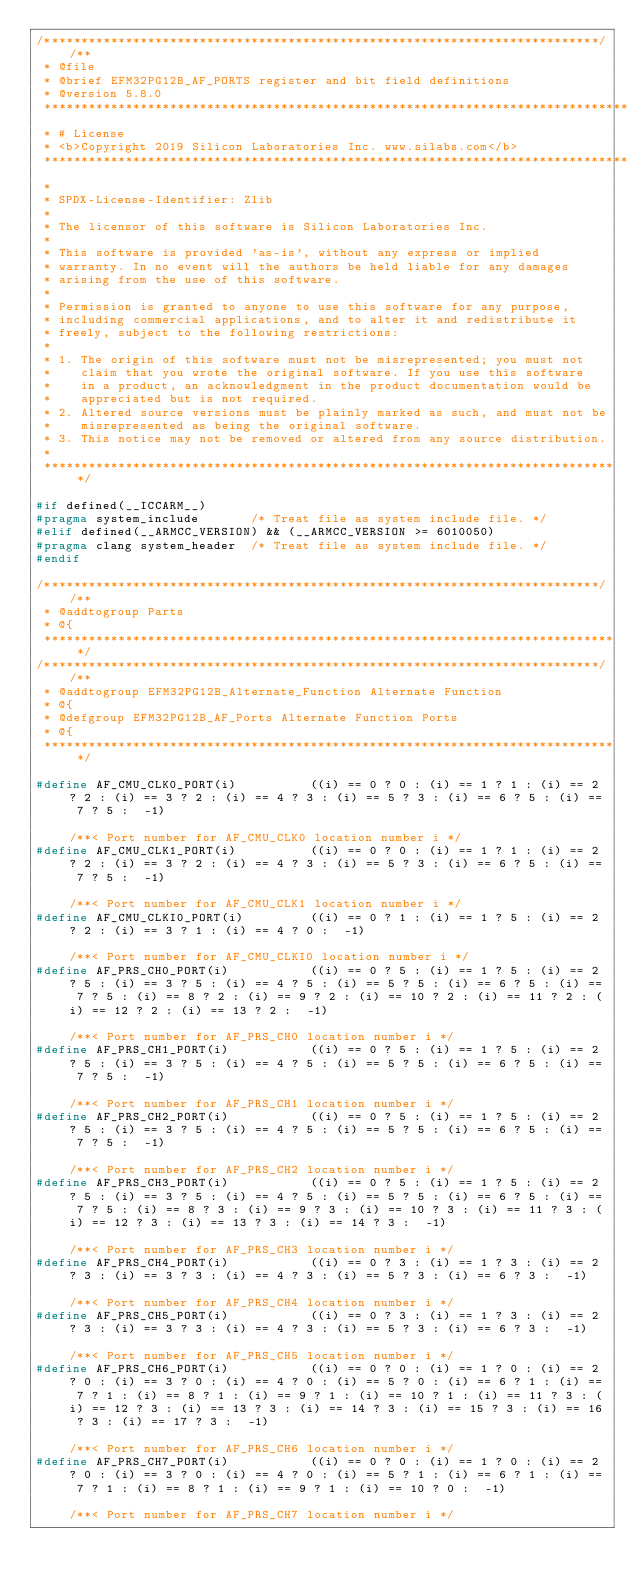<code> <loc_0><loc_0><loc_500><loc_500><_C_>/***************************************************************************//**
 * @file
 * @brief EFM32PG12B_AF_PORTS register and bit field definitions
 * @version 5.8.0
 *******************************************************************************
 * # License
 * <b>Copyright 2019 Silicon Laboratories Inc. www.silabs.com</b>
 *******************************************************************************
 *
 * SPDX-License-Identifier: Zlib
 *
 * The licensor of this software is Silicon Laboratories Inc.
 *
 * This software is provided 'as-is', without any express or implied
 * warranty. In no event will the authors be held liable for any damages
 * arising from the use of this software.
 *
 * Permission is granted to anyone to use this software for any purpose,
 * including commercial applications, and to alter it and redistribute it
 * freely, subject to the following restrictions:
 *
 * 1. The origin of this software must not be misrepresented; you must not
 *    claim that you wrote the original software. If you use this software
 *    in a product, an acknowledgment in the product documentation would be
 *    appreciated but is not required.
 * 2. Altered source versions must be plainly marked as such, and must not be
 *    misrepresented as being the original software.
 * 3. This notice may not be removed or altered from any source distribution.
 *
 ******************************************************************************/

#if defined(__ICCARM__)
#pragma system_include       /* Treat file as system include file. */
#elif defined(__ARMCC_VERSION) && (__ARMCC_VERSION >= 6010050)
#pragma clang system_header  /* Treat file as system include file. */
#endif

/***************************************************************************//**
 * @addtogroup Parts
 * @{
 ******************************************************************************/
/***************************************************************************//**
 * @addtogroup EFM32PG12B_Alternate_Function Alternate Function
 * @{
 * @defgroup EFM32PG12B_AF_Ports Alternate Function Ports
 * @{
 ******************************************************************************/

#define AF_CMU_CLK0_PORT(i)          ((i) == 0 ? 0 : (i) == 1 ? 1 : (i) == 2 ? 2 : (i) == 3 ? 2 : (i) == 4 ? 3 : (i) == 5 ? 3 : (i) == 6 ? 5 : (i) == 7 ? 5 :  -1)                                                                                                                                                                                                                                                                                                                                                                                                  /**< Port number for AF_CMU_CLK0 location number i */
#define AF_CMU_CLK1_PORT(i)          ((i) == 0 ? 0 : (i) == 1 ? 1 : (i) == 2 ? 2 : (i) == 3 ? 2 : (i) == 4 ? 3 : (i) == 5 ? 3 : (i) == 6 ? 5 : (i) == 7 ? 5 :  -1)                                                                                                                                                                                                                                                                                                                                                                                                  /**< Port number for AF_CMU_CLK1 location number i */
#define AF_CMU_CLKI0_PORT(i)         ((i) == 0 ? 1 : (i) == 1 ? 5 : (i) == 2 ? 2 : (i) == 3 ? 1 : (i) == 4 ? 0 :  -1)                                                                                                                                                                                                                                                                                                                                                                                                                                               /**< Port number for AF_CMU_CLKI0 location number i */
#define AF_PRS_CH0_PORT(i)           ((i) == 0 ? 5 : (i) == 1 ? 5 : (i) == 2 ? 5 : (i) == 3 ? 5 : (i) == 4 ? 5 : (i) == 5 ? 5 : (i) == 6 ? 5 : (i) == 7 ? 5 : (i) == 8 ? 2 : (i) == 9 ? 2 : (i) == 10 ? 2 : (i) == 11 ? 2 : (i) == 12 ? 2 : (i) == 13 ? 2 :  -1)                                                                                                                                                                                                                                                                                                    /**< Port number for AF_PRS_CH0 location number i */
#define AF_PRS_CH1_PORT(i)           ((i) == 0 ? 5 : (i) == 1 ? 5 : (i) == 2 ? 5 : (i) == 3 ? 5 : (i) == 4 ? 5 : (i) == 5 ? 5 : (i) == 6 ? 5 : (i) == 7 ? 5 :  -1)                                                                                                                                                                                                                                                                                                                                                                                                  /**< Port number for AF_PRS_CH1 location number i */
#define AF_PRS_CH2_PORT(i)           ((i) == 0 ? 5 : (i) == 1 ? 5 : (i) == 2 ? 5 : (i) == 3 ? 5 : (i) == 4 ? 5 : (i) == 5 ? 5 : (i) == 6 ? 5 : (i) == 7 ? 5 :  -1)                                                                                                                                                                                                                                                                                                                                                                                                  /**< Port number for AF_PRS_CH2 location number i */
#define AF_PRS_CH3_PORT(i)           ((i) == 0 ? 5 : (i) == 1 ? 5 : (i) == 2 ? 5 : (i) == 3 ? 5 : (i) == 4 ? 5 : (i) == 5 ? 5 : (i) == 6 ? 5 : (i) == 7 ? 5 : (i) == 8 ? 3 : (i) == 9 ? 3 : (i) == 10 ? 3 : (i) == 11 ? 3 : (i) == 12 ? 3 : (i) == 13 ? 3 : (i) == 14 ? 3 :  -1)                                                                                                                                                                                                                                                                                    /**< Port number for AF_PRS_CH3 location number i */
#define AF_PRS_CH4_PORT(i)           ((i) == 0 ? 3 : (i) == 1 ? 3 : (i) == 2 ? 3 : (i) == 3 ? 3 : (i) == 4 ? 3 : (i) == 5 ? 3 : (i) == 6 ? 3 :  -1)                                                                                                                                                                                                                                                                                                                                                                                                                 /**< Port number for AF_PRS_CH4 location number i */
#define AF_PRS_CH5_PORT(i)           ((i) == 0 ? 3 : (i) == 1 ? 3 : (i) == 2 ? 3 : (i) == 3 ? 3 : (i) == 4 ? 3 : (i) == 5 ? 3 : (i) == 6 ? 3 :  -1)                                                                                                                                                                                                                                                                                                                                                                                                                 /**< Port number for AF_PRS_CH5 location number i */
#define AF_PRS_CH6_PORT(i)           ((i) == 0 ? 0 : (i) == 1 ? 0 : (i) == 2 ? 0 : (i) == 3 ? 0 : (i) == 4 ? 0 : (i) == 5 ? 0 : (i) == 6 ? 1 : (i) == 7 ? 1 : (i) == 8 ? 1 : (i) == 9 ? 1 : (i) == 10 ? 1 : (i) == 11 ? 3 : (i) == 12 ? 3 : (i) == 13 ? 3 : (i) == 14 ? 3 : (i) == 15 ? 3 : (i) == 16 ? 3 : (i) == 17 ? 3 :  -1)                                                                                                                                                                                                                                    /**< Port number for AF_PRS_CH6 location number i */
#define AF_PRS_CH7_PORT(i)           ((i) == 0 ? 0 : (i) == 1 ? 0 : (i) == 2 ? 0 : (i) == 3 ? 0 : (i) == 4 ? 0 : (i) == 5 ? 1 : (i) == 6 ? 1 : (i) == 7 ? 1 : (i) == 8 ? 1 : (i) == 9 ? 1 : (i) == 10 ? 0 :  -1)                                                                                                                                                                                                                                                                                                                                                    /**< Port number for AF_PRS_CH7 location number i */</code> 